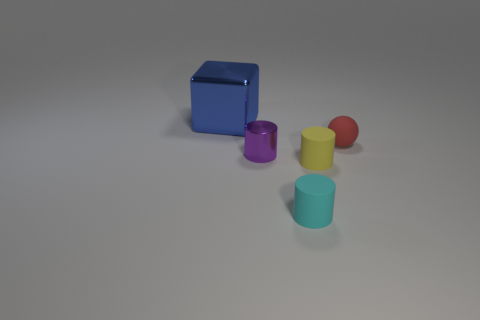Add 3 tiny cyan things. How many objects exist? 8 Subtract all cubes. How many objects are left? 4 Subtract 0 gray cubes. How many objects are left? 5 Subtract all small yellow shiny cylinders. Subtract all small things. How many objects are left? 1 Add 4 small cyan cylinders. How many small cyan cylinders are left? 5 Add 2 big green shiny cylinders. How many big green shiny cylinders exist? 2 